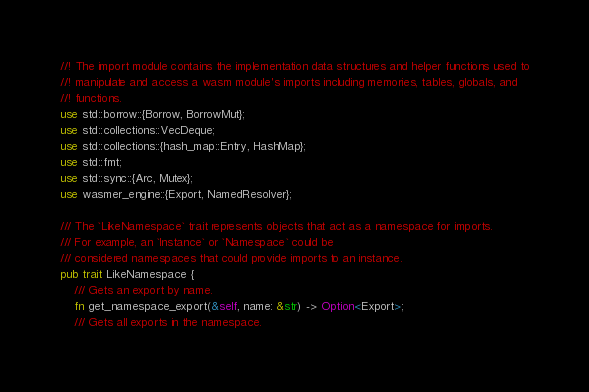Convert code to text. <code><loc_0><loc_0><loc_500><loc_500><_Rust_>//! The import module contains the implementation data structures and helper functions used to
//! manipulate and access a wasm module's imports including memories, tables, globals, and
//! functions.
use std::borrow::{Borrow, BorrowMut};
use std::collections::VecDeque;
use std::collections::{hash_map::Entry, HashMap};
use std::fmt;
use std::sync::{Arc, Mutex};
use wasmer_engine::{Export, NamedResolver};

/// The `LikeNamespace` trait represents objects that act as a namespace for imports.
/// For example, an `Instance` or `Namespace` could be
/// considered namespaces that could provide imports to an instance.
pub trait LikeNamespace {
    /// Gets an export by name.
    fn get_namespace_export(&self, name: &str) -> Option<Export>;
    /// Gets all exports in the namespace.</code> 